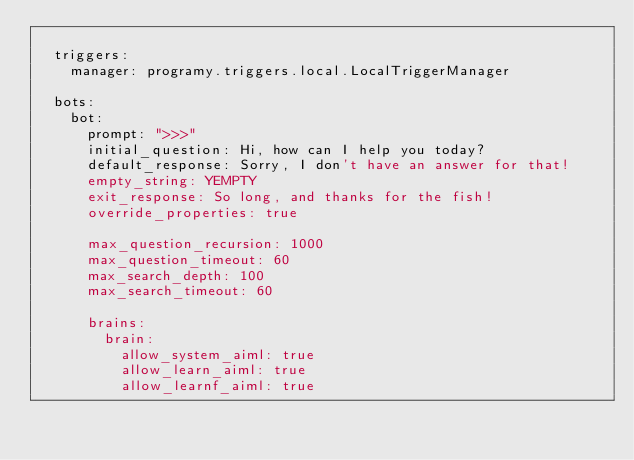Convert code to text. <code><loc_0><loc_0><loc_500><loc_500><_YAML_>
  triggers:
    manager: programy.triggers.local.LocalTriggerManager

  bots:
    bot:
      prompt: ">>>"
      initial_question: Hi, how can I help you today?
      default_response: Sorry, I don't have an answer for that!
      empty_string: YEMPTY
      exit_response: So long, and thanks for the fish!
      override_properties: true

      max_question_recursion: 1000
      max_question_timeout: 60
      max_search_depth: 100
      max_search_timeout: 60

      brains:
        brain:
          allow_system_aiml: true
          allow_learn_aiml: true
          allow_learnf_aiml: true

</code> 